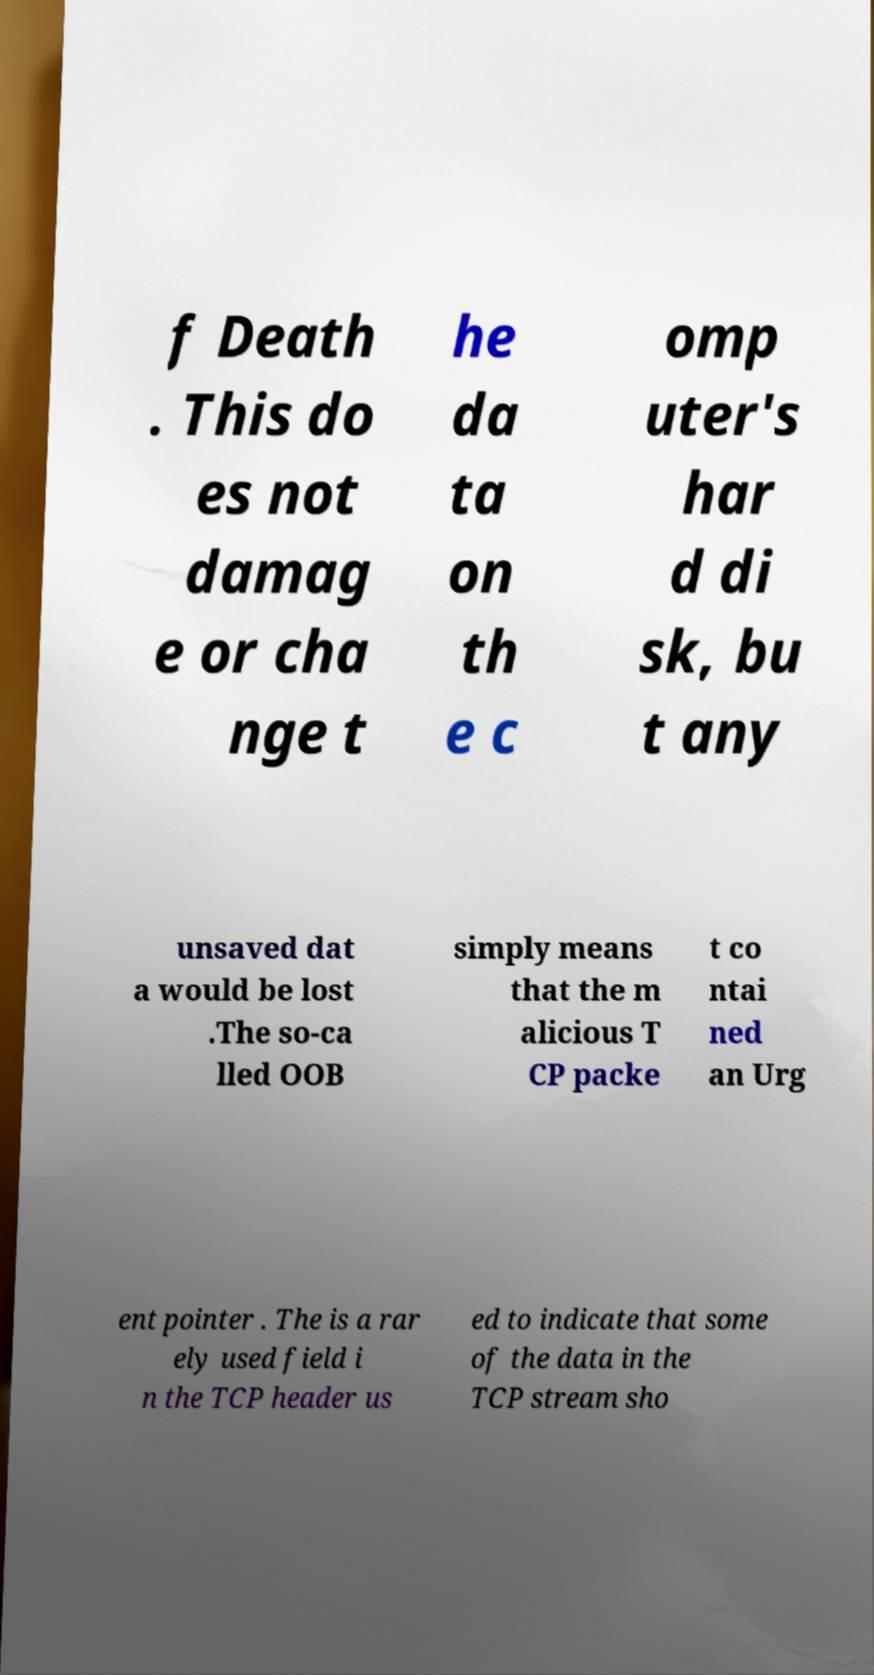Can you accurately transcribe the text from the provided image for me? f Death . This do es not damag e or cha nge t he da ta on th e c omp uter's har d di sk, bu t any unsaved dat a would be lost .The so-ca lled OOB simply means that the m alicious T CP packe t co ntai ned an Urg ent pointer . The is a rar ely used field i n the TCP header us ed to indicate that some of the data in the TCP stream sho 